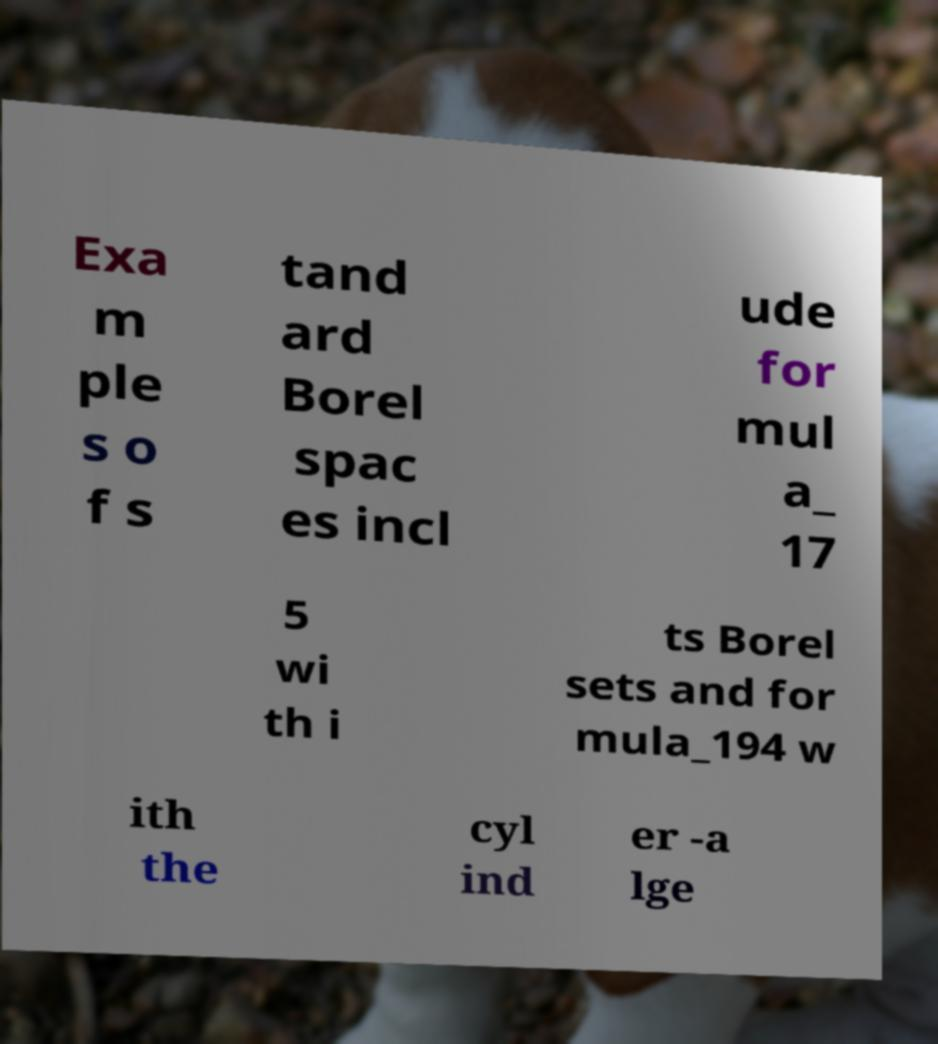Please read and relay the text visible in this image. What does it say? Exa m ple s o f s tand ard Borel spac es incl ude for mul a_ 17 5 wi th i ts Borel sets and for mula_194 w ith the cyl ind er -a lge 